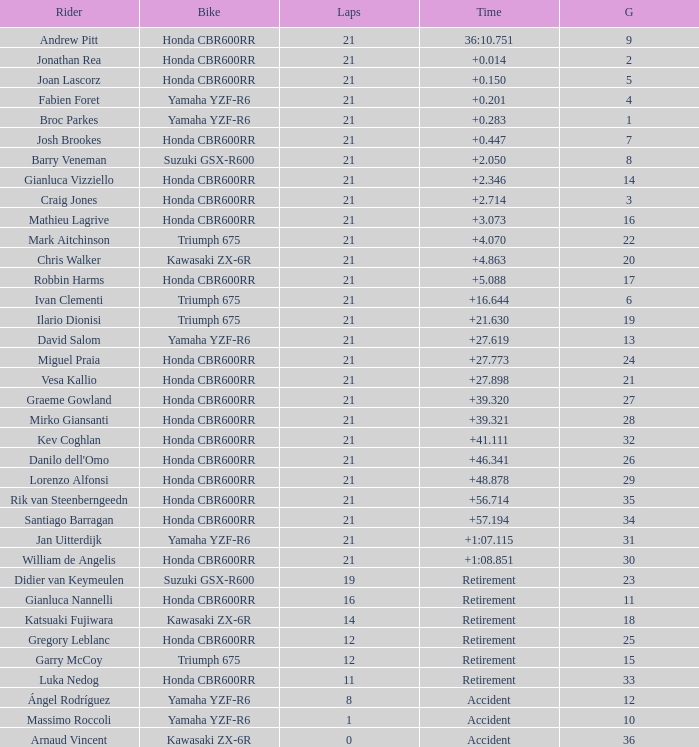What is the cumulative number of laps completed by the driver with a grid below 17 and a time of + None. 